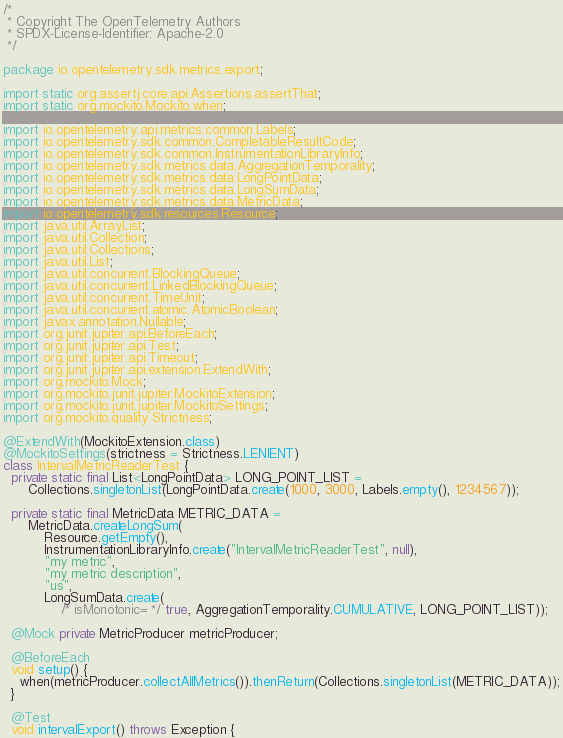Convert code to text. <code><loc_0><loc_0><loc_500><loc_500><_Java_>/*
 * Copyright The OpenTelemetry Authors
 * SPDX-License-Identifier: Apache-2.0
 */

package io.opentelemetry.sdk.metrics.export;

import static org.assertj.core.api.Assertions.assertThat;
import static org.mockito.Mockito.when;

import io.opentelemetry.api.metrics.common.Labels;
import io.opentelemetry.sdk.common.CompletableResultCode;
import io.opentelemetry.sdk.common.InstrumentationLibraryInfo;
import io.opentelemetry.sdk.metrics.data.AggregationTemporality;
import io.opentelemetry.sdk.metrics.data.LongPointData;
import io.opentelemetry.sdk.metrics.data.LongSumData;
import io.opentelemetry.sdk.metrics.data.MetricData;
import io.opentelemetry.sdk.resources.Resource;
import java.util.ArrayList;
import java.util.Collection;
import java.util.Collections;
import java.util.List;
import java.util.concurrent.BlockingQueue;
import java.util.concurrent.LinkedBlockingQueue;
import java.util.concurrent.TimeUnit;
import java.util.concurrent.atomic.AtomicBoolean;
import javax.annotation.Nullable;
import org.junit.jupiter.api.BeforeEach;
import org.junit.jupiter.api.Test;
import org.junit.jupiter.api.Timeout;
import org.junit.jupiter.api.extension.ExtendWith;
import org.mockito.Mock;
import org.mockito.junit.jupiter.MockitoExtension;
import org.mockito.junit.jupiter.MockitoSettings;
import org.mockito.quality.Strictness;

@ExtendWith(MockitoExtension.class)
@MockitoSettings(strictness = Strictness.LENIENT)
class IntervalMetricReaderTest {
  private static final List<LongPointData> LONG_POINT_LIST =
      Collections.singletonList(LongPointData.create(1000, 3000, Labels.empty(), 1234567));

  private static final MetricData METRIC_DATA =
      MetricData.createLongSum(
          Resource.getEmpty(),
          InstrumentationLibraryInfo.create("IntervalMetricReaderTest", null),
          "my metric",
          "my metric description",
          "us",
          LongSumData.create(
              /* isMonotonic= */ true, AggregationTemporality.CUMULATIVE, LONG_POINT_LIST));

  @Mock private MetricProducer metricProducer;

  @BeforeEach
  void setup() {
    when(metricProducer.collectAllMetrics()).thenReturn(Collections.singletonList(METRIC_DATA));
  }

  @Test
  void intervalExport() throws Exception {</code> 